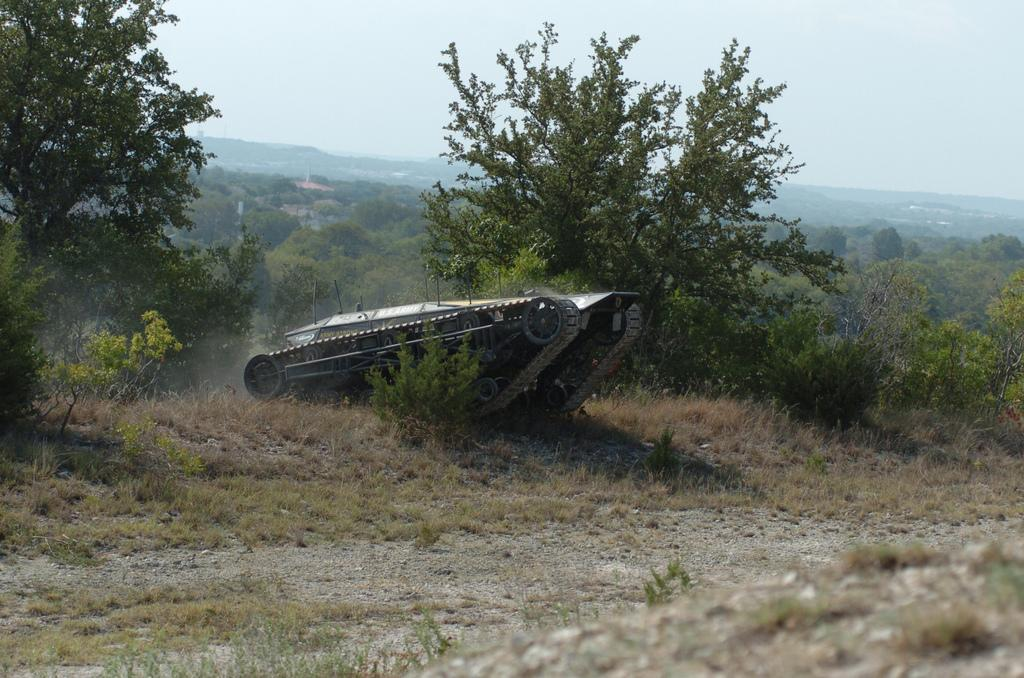What type of vegetation is present in the image? There is grass in the image. What type of vehicle can be seen in the image? There is a tank in the image. What can be seen in the background of the image? There are trees and the sky visible in the background of the image. What brand of toothpaste is advertised on the tank in the image? There is no toothpaste or advertisement present in the image. What type of carriage is being pulled by the horses in the image? There are no horses or carriages present in the image. 